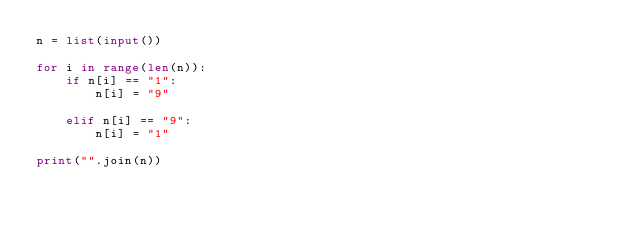Convert code to text. <code><loc_0><loc_0><loc_500><loc_500><_Python_>n = list(input())

for i in range(len(n)):
    if n[i] == "1":
        n[i] = "9"

    elif n[i] == "9":
        n[i] = "1"

print("".join(n))</code> 